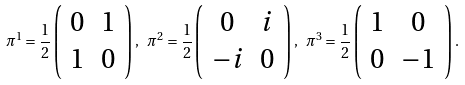<formula> <loc_0><loc_0><loc_500><loc_500>\pi ^ { 1 } = \frac { 1 } { 2 } \left ( \begin{array} { c c } 0 & 1 \\ 1 & 0 \end{array} \right ) , \ \pi ^ { 2 } = \frac { 1 } { 2 } \left ( \begin{array} { c c } 0 & i \\ - i & 0 \end{array} \right ) , \ \pi ^ { 3 } = \frac { 1 } { 2 } \left ( \begin{array} { c c } 1 & 0 \\ 0 & - 1 \end{array} \right ) .</formula> 